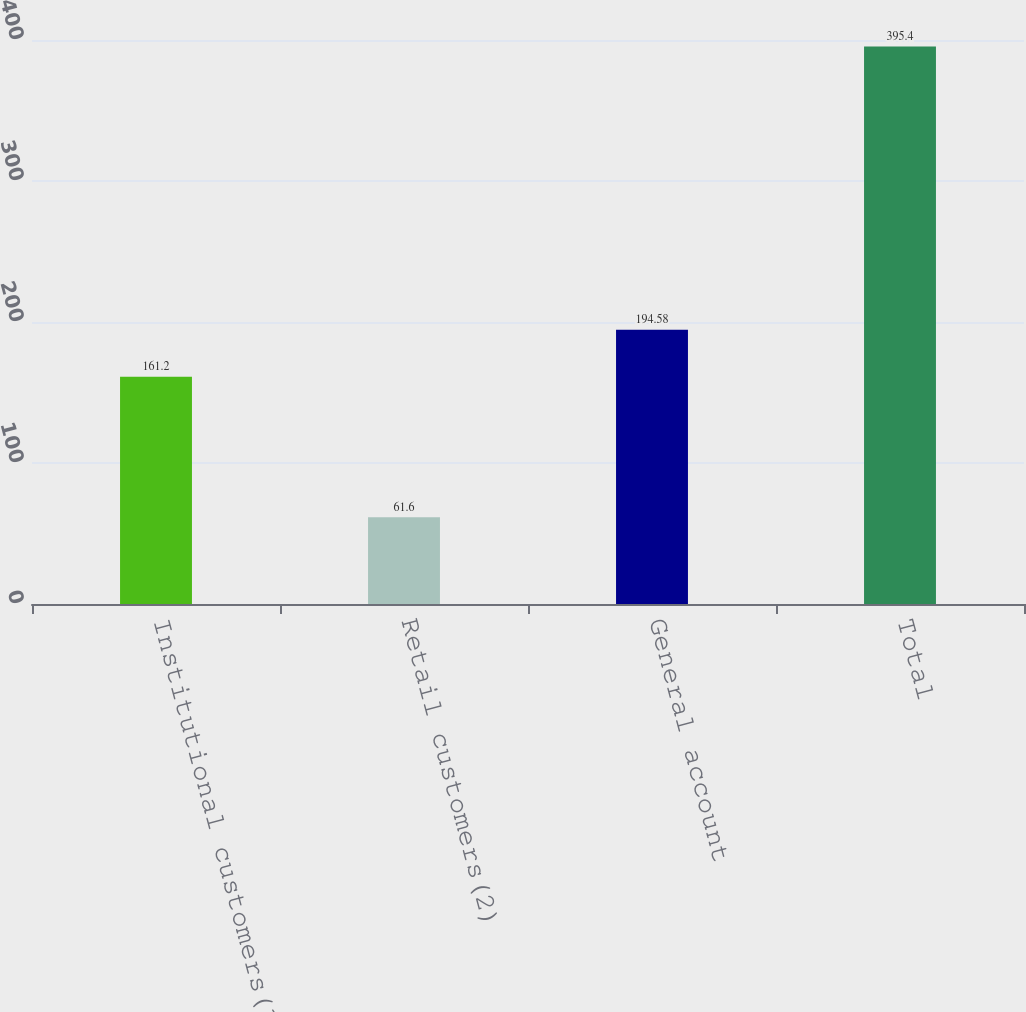Convert chart. <chart><loc_0><loc_0><loc_500><loc_500><bar_chart><fcel>Institutional customers(1)<fcel>Retail customers(2)<fcel>General account<fcel>Total<nl><fcel>161.2<fcel>61.6<fcel>194.58<fcel>395.4<nl></chart> 